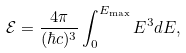<formula> <loc_0><loc_0><loc_500><loc_500>\mathcal { E } = \frac { 4 \pi } { ( \hbar { c } ) ^ { 3 } } \int _ { 0 } ^ { E _ { \max } } E ^ { 3 } d E ,</formula> 